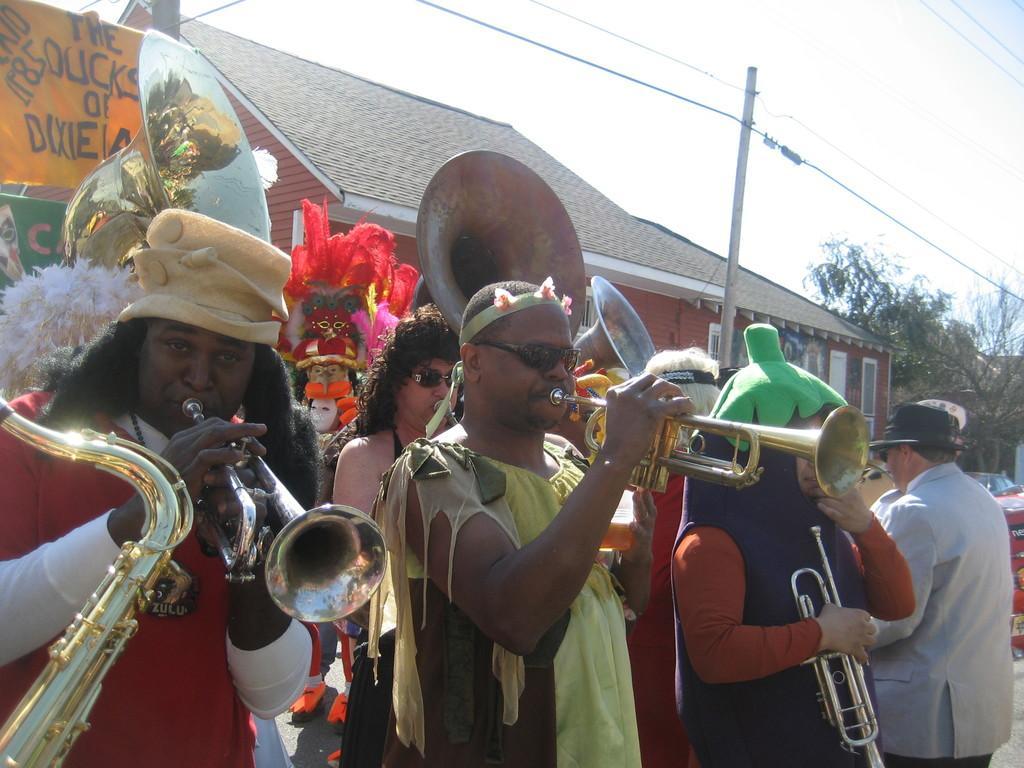Could you give a brief overview of what you see in this image? In this image we can see few people playing musical instruments and there are few buildings, trees, a pole with wires and the sky in the background. 